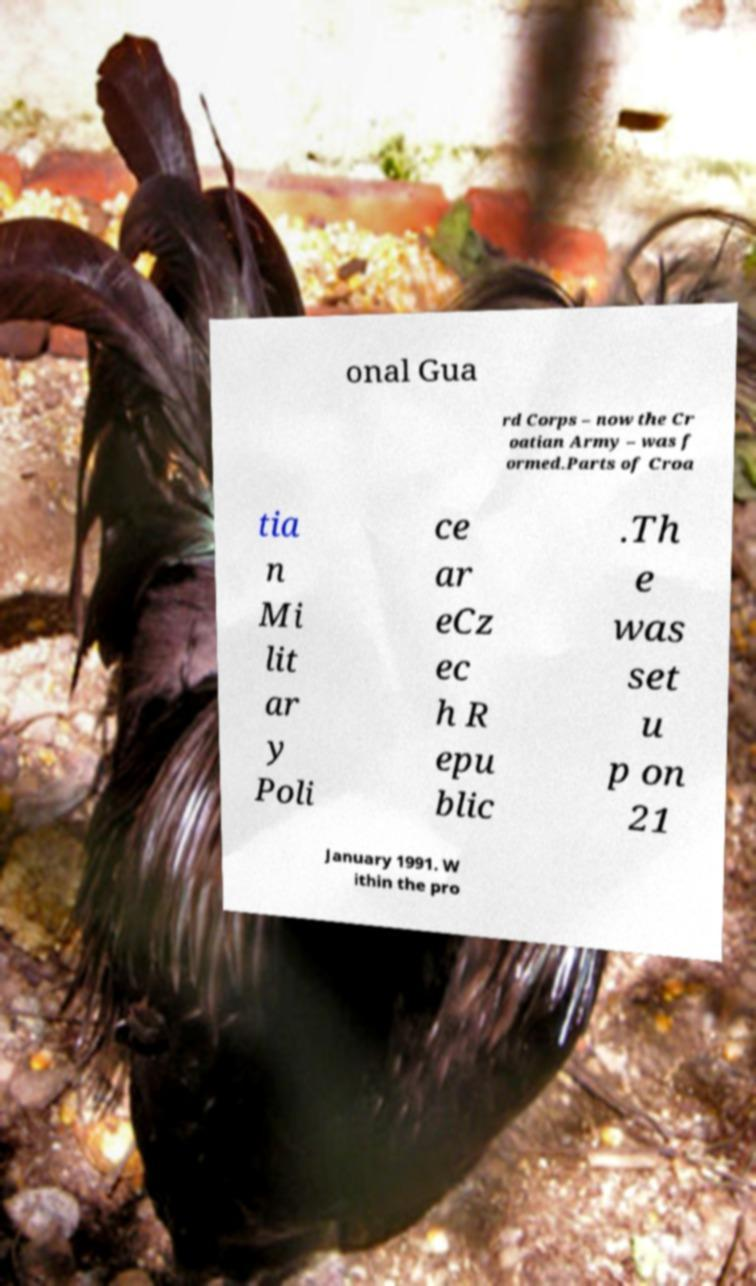Could you assist in decoding the text presented in this image and type it out clearly? onal Gua rd Corps – now the Cr oatian Army – was f ormed.Parts of Croa tia n Mi lit ar y Poli ce ar eCz ec h R epu blic .Th e was set u p on 21 January 1991. W ithin the pro 